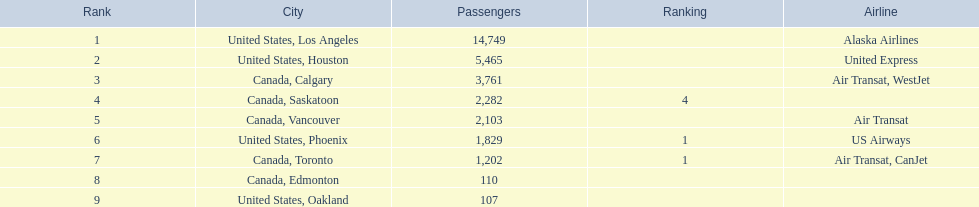Los angeles and what other city had about 19,000 passenger combined Canada, Calgary. 